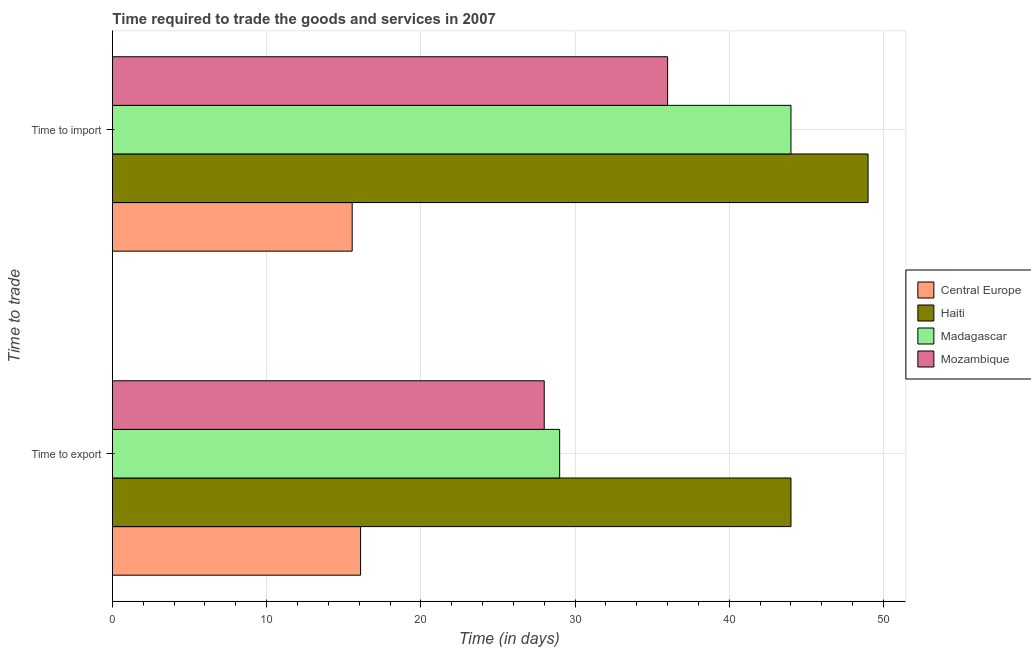How many groups of bars are there?
Provide a succinct answer. 2. Are the number of bars on each tick of the Y-axis equal?
Provide a short and direct response. Yes. How many bars are there on the 1st tick from the top?
Make the answer very short. 4. What is the label of the 1st group of bars from the top?
Offer a very short reply. Time to import. What is the time to export in Central Europe?
Offer a very short reply. 16.09. Across all countries, what is the minimum time to export?
Your answer should be very brief. 16.09. In which country was the time to export maximum?
Offer a very short reply. Haiti. In which country was the time to export minimum?
Your answer should be compact. Central Europe. What is the total time to export in the graph?
Ensure brevity in your answer.  117.09. What is the difference between the time to import in Haiti and that in Madagascar?
Your answer should be very brief. 5. What is the difference between the time to import in Central Europe and the time to export in Haiti?
Provide a short and direct response. -28.45. What is the average time to export per country?
Your response must be concise. 29.27. What is the ratio of the time to export in Central Europe to that in Haiti?
Give a very brief answer. 0.37. In how many countries, is the time to export greater than the average time to export taken over all countries?
Your response must be concise. 1. What does the 4th bar from the top in Time to import represents?
Ensure brevity in your answer.  Central Europe. What does the 2nd bar from the bottom in Time to export represents?
Your response must be concise. Haiti. Are all the bars in the graph horizontal?
Your answer should be compact. Yes. Are the values on the major ticks of X-axis written in scientific E-notation?
Your answer should be compact. No. Does the graph contain any zero values?
Provide a short and direct response. No. How are the legend labels stacked?
Your answer should be compact. Vertical. What is the title of the graph?
Ensure brevity in your answer.  Time required to trade the goods and services in 2007. What is the label or title of the X-axis?
Provide a succinct answer. Time (in days). What is the label or title of the Y-axis?
Your response must be concise. Time to trade. What is the Time (in days) of Central Europe in Time to export?
Provide a short and direct response. 16.09. What is the Time (in days) of Madagascar in Time to export?
Give a very brief answer. 29. What is the Time (in days) of Central Europe in Time to import?
Your answer should be compact. 15.55. What is the Time (in days) in Mozambique in Time to import?
Keep it short and to the point. 36. Across all Time to trade, what is the maximum Time (in days) in Central Europe?
Make the answer very short. 16.09. Across all Time to trade, what is the minimum Time (in days) of Central Europe?
Make the answer very short. 15.55. What is the total Time (in days) in Central Europe in the graph?
Provide a succinct answer. 31.64. What is the total Time (in days) in Haiti in the graph?
Provide a short and direct response. 93. What is the total Time (in days) of Madagascar in the graph?
Offer a terse response. 73. What is the difference between the Time (in days) of Central Europe in Time to export and that in Time to import?
Your answer should be very brief. 0.55. What is the difference between the Time (in days) in Haiti in Time to export and that in Time to import?
Provide a succinct answer. -5. What is the difference between the Time (in days) of Madagascar in Time to export and that in Time to import?
Your answer should be very brief. -15. What is the difference between the Time (in days) in Central Europe in Time to export and the Time (in days) in Haiti in Time to import?
Offer a very short reply. -32.91. What is the difference between the Time (in days) of Central Europe in Time to export and the Time (in days) of Madagascar in Time to import?
Offer a terse response. -27.91. What is the difference between the Time (in days) of Central Europe in Time to export and the Time (in days) of Mozambique in Time to import?
Your response must be concise. -19.91. What is the difference between the Time (in days) of Haiti in Time to export and the Time (in days) of Madagascar in Time to import?
Keep it short and to the point. 0. What is the difference between the Time (in days) in Haiti in Time to export and the Time (in days) in Mozambique in Time to import?
Ensure brevity in your answer.  8. What is the difference between the Time (in days) in Madagascar in Time to export and the Time (in days) in Mozambique in Time to import?
Your answer should be very brief. -7. What is the average Time (in days) in Central Europe per Time to trade?
Your answer should be very brief. 15.82. What is the average Time (in days) in Haiti per Time to trade?
Your answer should be very brief. 46.5. What is the average Time (in days) of Madagascar per Time to trade?
Your answer should be very brief. 36.5. What is the difference between the Time (in days) of Central Europe and Time (in days) of Haiti in Time to export?
Provide a succinct answer. -27.91. What is the difference between the Time (in days) in Central Europe and Time (in days) in Madagascar in Time to export?
Provide a succinct answer. -12.91. What is the difference between the Time (in days) of Central Europe and Time (in days) of Mozambique in Time to export?
Your answer should be compact. -11.91. What is the difference between the Time (in days) in Haiti and Time (in days) in Madagascar in Time to export?
Your response must be concise. 15. What is the difference between the Time (in days) of Haiti and Time (in days) of Mozambique in Time to export?
Offer a very short reply. 16. What is the difference between the Time (in days) in Central Europe and Time (in days) in Haiti in Time to import?
Offer a very short reply. -33.45. What is the difference between the Time (in days) in Central Europe and Time (in days) in Madagascar in Time to import?
Give a very brief answer. -28.45. What is the difference between the Time (in days) in Central Europe and Time (in days) in Mozambique in Time to import?
Offer a very short reply. -20.45. What is the difference between the Time (in days) in Haiti and Time (in days) in Mozambique in Time to import?
Provide a short and direct response. 13. What is the difference between the Time (in days) of Madagascar and Time (in days) of Mozambique in Time to import?
Provide a succinct answer. 8. What is the ratio of the Time (in days) in Central Europe in Time to export to that in Time to import?
Your response must be concise. 1.04. What is the ratio of the Time (in days) in Haiti in Time to export to that in Time to import?
Give a very brief answer. 0.9. What is the ratio of the Time (in days) of Madagascar in Time to export to that in Time to import?
Your response must be concise. 0.66. What is the ratio of the Time (in days) in Mozambique in Time to export to that in Time to import?
Your response must be concise. 0.78. What is the difference between the highest and the second highest Time (in days) of Central Europe?
Offer a terse response. 0.55. What is the difference between the highest and the second highest Time (in days) in Madagascar?
Provide a short and direct response. 15. What is the difference between the highest and the lowest Time (in days) in Central Europe?
Your answer should be very brief. 0.55. 